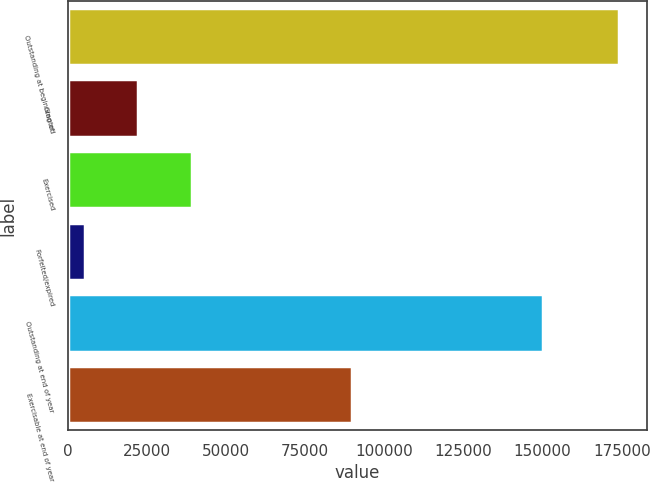Convert chart. <chart><loc_0><loc_0><loc_500><loc_500><bar_chart><fcel>Outstanding at beginning of<fcel>Granted<fcel>Exercised<fcel>Forfeited/expired<fcel>Outstanding at end of year<fcel>Exercisable at end of year<nl><fcel>174261<fcel>22371.6<fcel>39248.2<fcel>5495<fcel>150149<fcel>89652<nl></chart> 